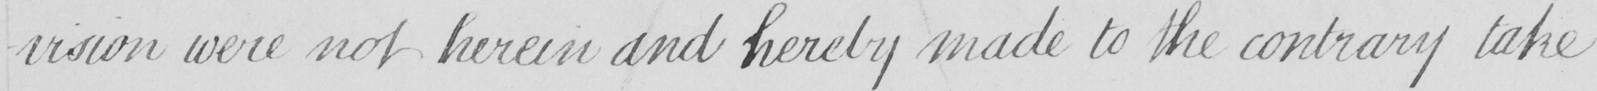What is written in this line of handwriting? -vision were not herein and hereby made to the contrary take 